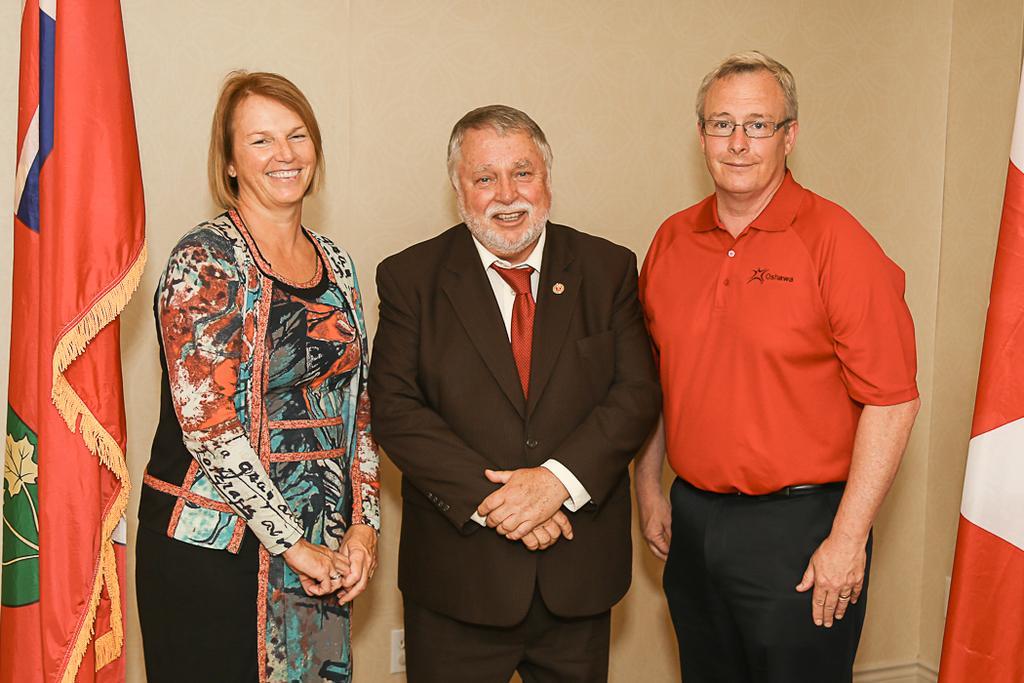Describe this image in one or two sentences. In this image, we can see people standing and one of them is wearing a coat and a tie and a man wearing glasses. In the background, there are flags and a wall. 